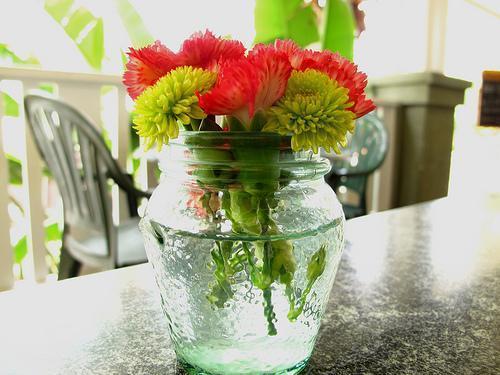How many green flowers are there?
Give a very brief answer. 2. How many green flowers are in the vase?
Give a very brief answer. 2. How many black flower are there?
Give a very brief answer. 0. 